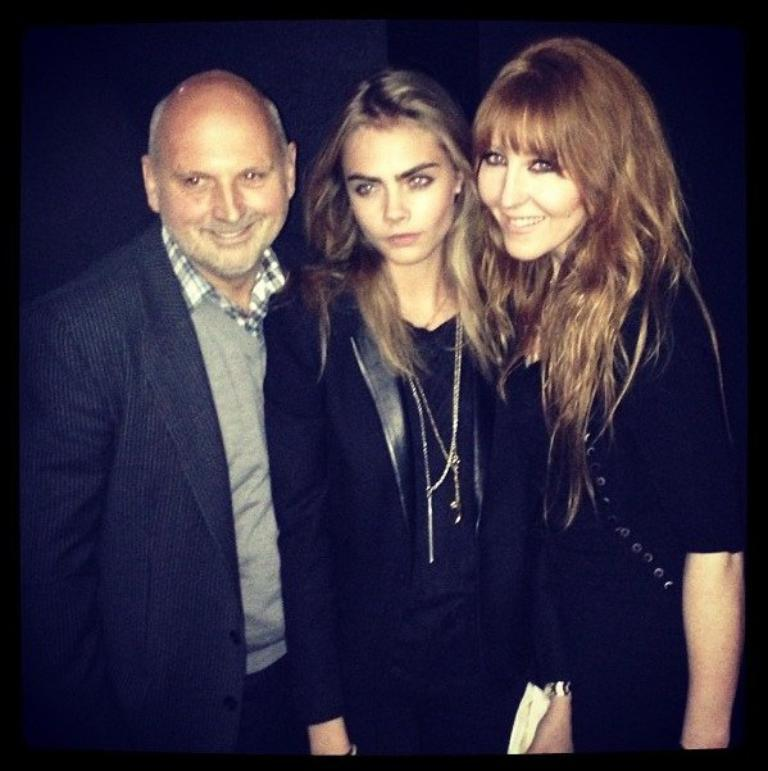How many individuals are present in the image? There are three people in the image. What can be observed about the background of the image? The background of the image is dark. What type of doctor is standing next to the cow in the image? There is no doctor or cow present in the image; it only features three people. 